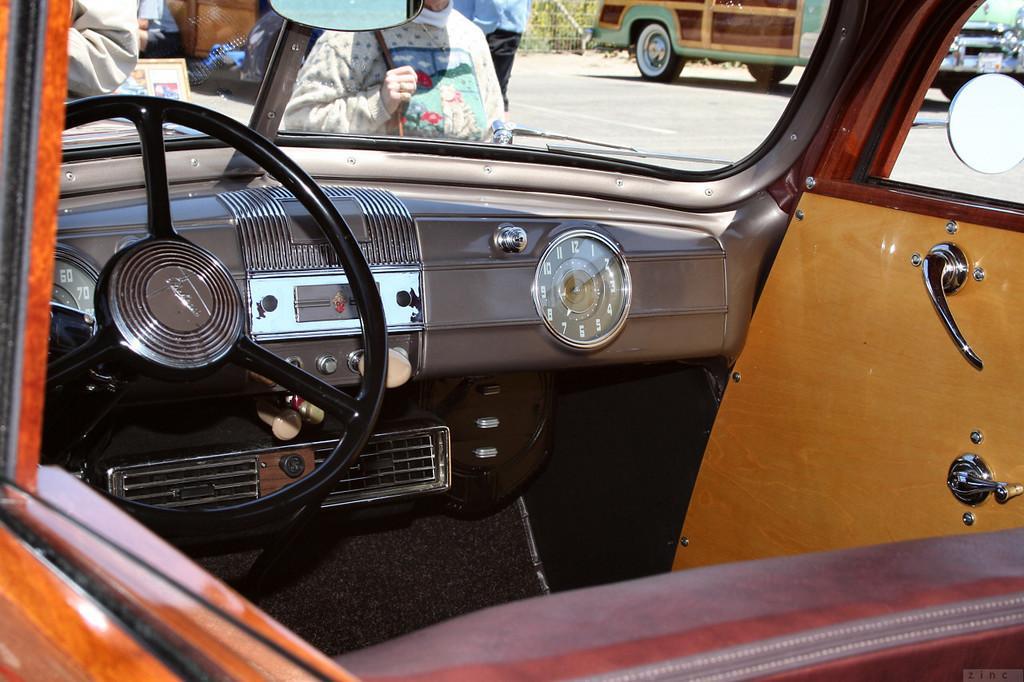How would you summarize this image in a sentence or two? This is the inside view of a vehicle where we can see a meter, few devices and a steering. On the right, there is a door and at the bottom, there is the seat of that vehicle. In the background, there are few people and a vehicle on the road. 